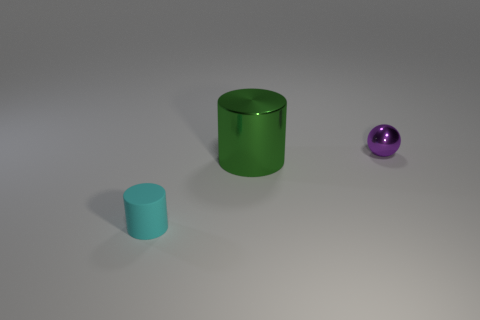There is a object that is behind the green cylinder; is it the same size as the big green cylinder?
Give a very brief answer. No. Are there more small things right of the tiny matte thing than purple balls that are behind the small purple metal thing?
Your answer should be compact. Yes. There is a thing that is to the right of the tiny cyan thing and in front of the small purple metallic sphere; what is its shape?
Your answer should be compact. Cylinder. There is a small object that is to the left of the tiny purple shiny ball; what is its shape?
Your answer should be compact. Cylinder. There is a cylinder that is in front of the metal thing in front of the metal thing that is to the right of the green metal thing; what size is it?
Make the answer very short. Small. Does the green shiny thing have the same shape as the small cyan matte object?
Provide a succinct answer. Yes. What size is the object that is in front of the shiny sphere and on the right side of the cyan rubber cylinder?
Your response must be concise. Large. What material is the other tiny thing that is the same shape as the green metallic object?
Provide a short and direct response. Rubber. What is the cylinder that is to the right of the thing on the left side of the green shiny object made of?
Give a very brief answer. Metal. There is a large green shiny thing; is its shape the same as the object that is on the left side of the large thing?
Offer a terse response. Yes. 